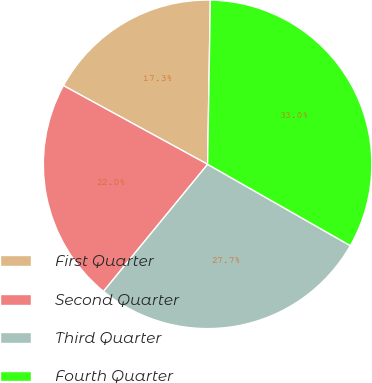<chart> <loc_0><loc_0><loc_500><loc_500><pie_chart><fcel>First Quarter<fcel>Second Quarter<fcel>Third Quarter<fcel>Fourth Quarter<nl><fcel>17.31%<fcel>22.03%<fcel>27.68%<fcel>32.98%<nl></chart> 